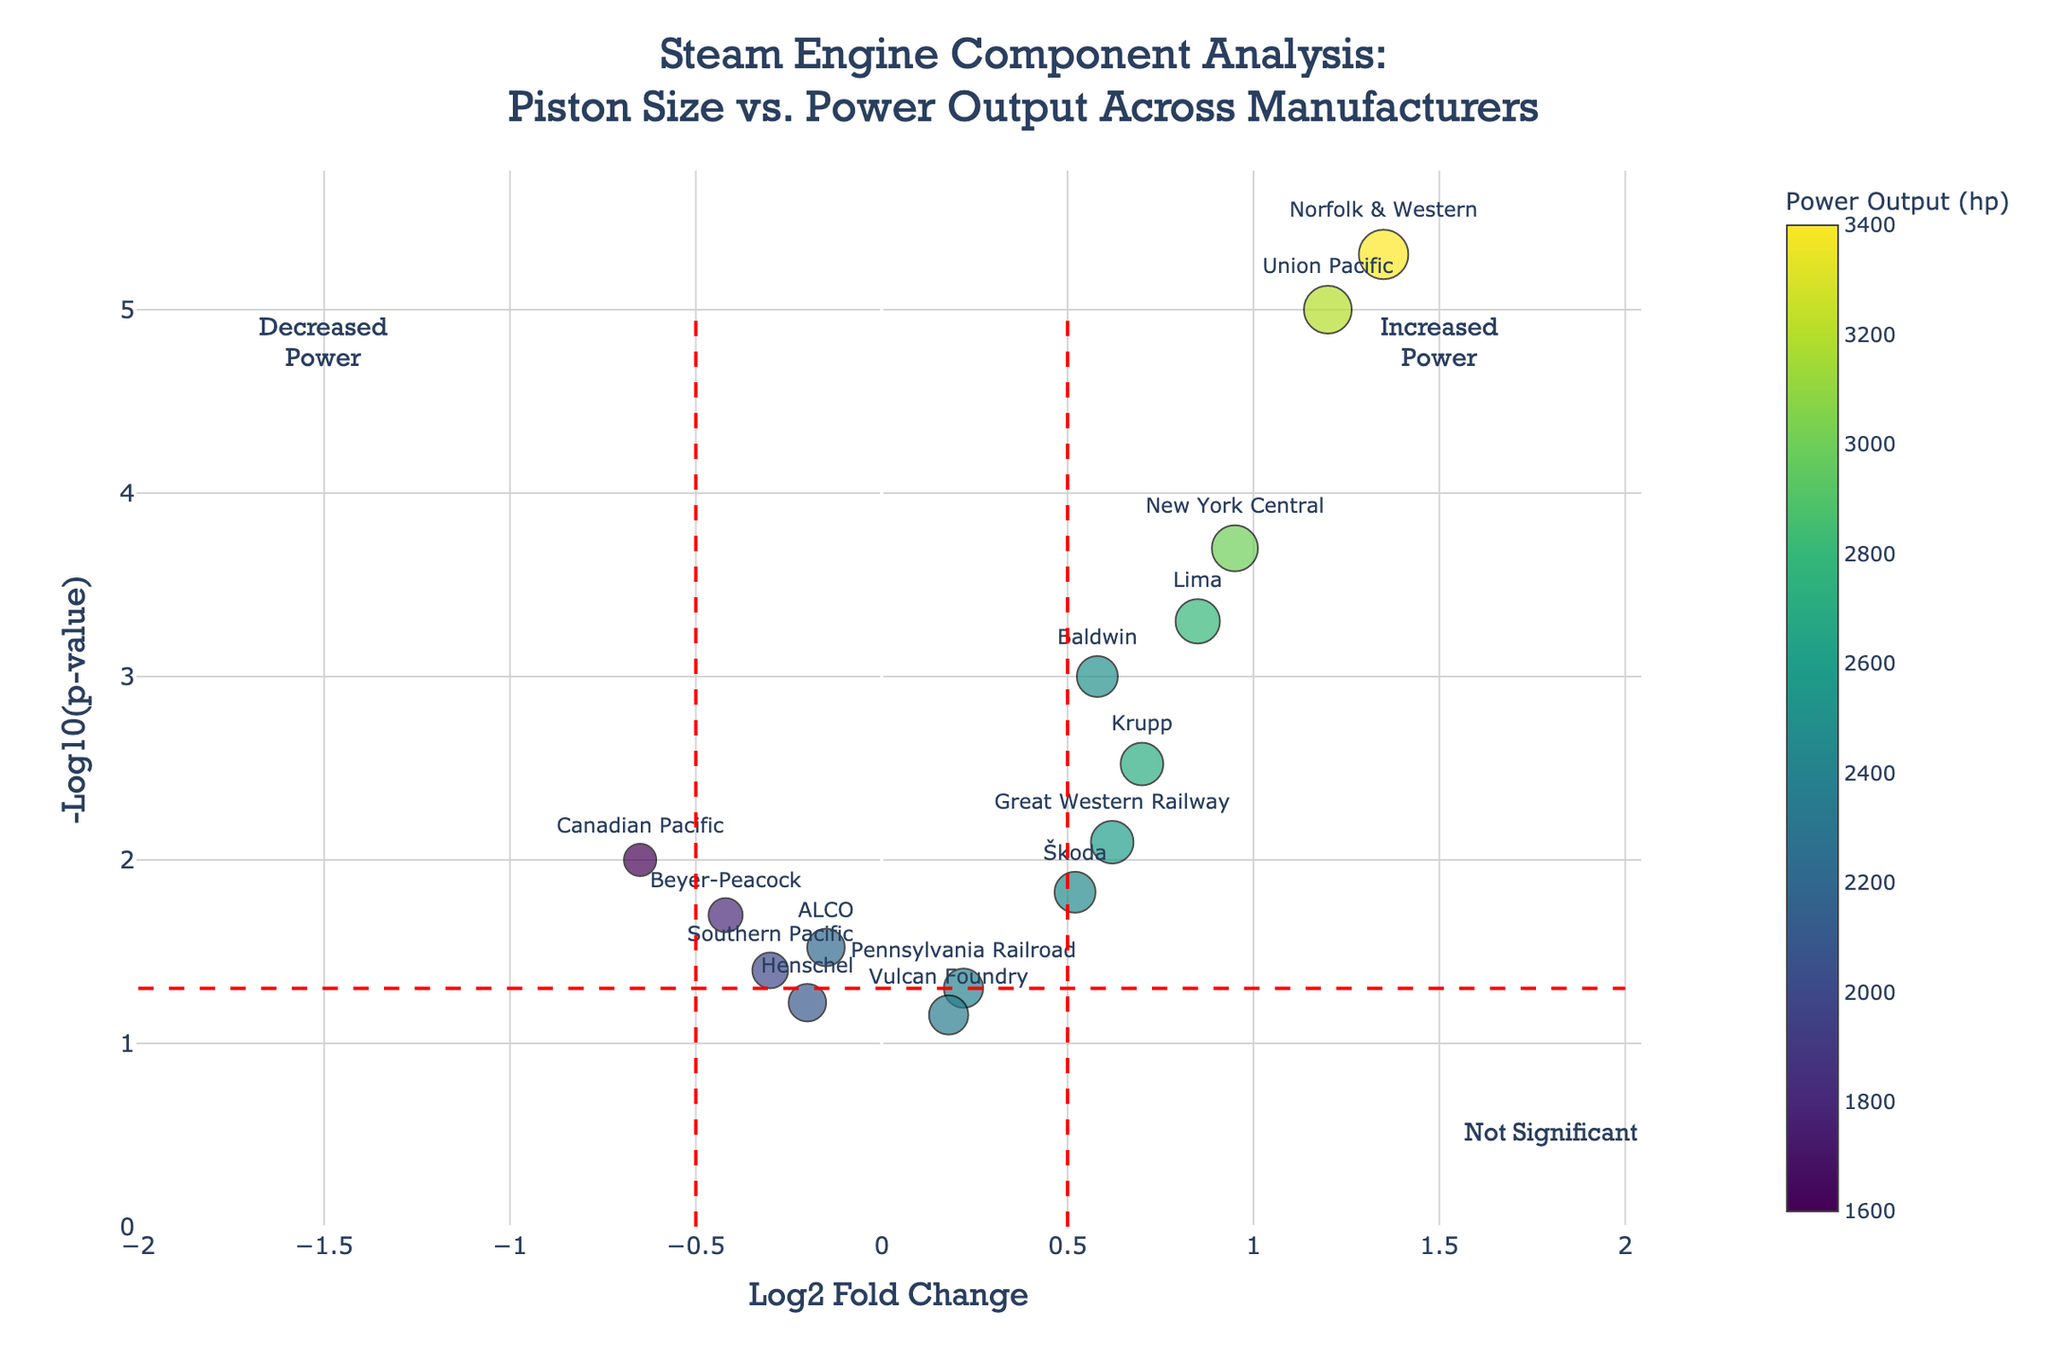What does the title of the plot indicate? The title, "Steam Engine Component Analysis: Piston Size vs. Power Output Across Manufacturers," indicates that the plot evaluates the relationship between piston size (expressed as fold changes) and power output among different steam engine manufacturers.
Answer: Steam Engine Component Analysis: Piston Size vs. Power Output Across Manufacturers Which manufacturer has the highest power output? According to the color scale and positioning on the y-axis, Norfolk & Western has the highest power output with a value of 3400 hp.
Answer: Norfolk & Western What are the axis labels in the plot? The x-axis is labeled "Log2 Fold Change" and the y-axis is labeled "-Log10(p-value)," which means the plot shows fold changes on the x-axis and the negative log of the p-values on the y-axis.
Answer: Log2 Fold Change and -Log10(p-value) How many data points represent steam engines with significantly increased power? Data points with log2 fold change > 0.5 and -log10(p-value) > 1.3 represent significantly increased power; counting these points indicates there are 5: Baldwin, Lima, Union Pacific, New York Central, and Norfolk & Western.
Answer: 5 Which manufacturers have a decreased power output? The data points with log2 fold changes below -0.5 indicate decreased power output. The manufacturers are Canadian Pacific and Beyer-Peacock.
Answer: Canadian Pacific and Beyer-Peacock What is the piston diameter of Baldwin steam engines? By examining Baldwin's data point, its marker size on the plot matches a piston diameter of 24 inches.
Answer: 24 inches Which steam engine manufacturer has the smallest piston diameter but increased power output? From the plot, Canadian Pacific and Beyer-Peacock have the smallest piston diameters (19 and 20 inches respectively), but both have decreased power output. Therefore, there isn't any with increased power output.
Answer: None What threshold separates significant from non-significant p-values? The horizontal red dashed line on the plot at y = 1.3 represents the threshold for significance in the -log10(p-value) scale, corresponding to a p-value of about 0.05.
Answer: 1.3 How does the power output of Škoda compare to that of Great Western Railway in terms of fold change? Škoda and Great Western Railway both have positive fold changes, but Škoda's log2 fold change (0.52) is slightly lower than that of Great Western Railway (0.62).
Answer: Škoda has a lower fold change than Great Western Railway What is the color scale used for in the volcano plot? The color scale represents the power output (in hp) of the steam engines, with colors ranging according to the Viridis palette and higher power output aligning with the upper end of the color scale.
Answer: Power output (hp) 